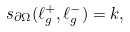Convert formula to latex. <formula><loc_0><loc_0><loc_500><loc_500>s _ { \partial \Omega } ( \ell ^ { + } _ { g } , \ell ^ { - } _ { g } ) = k ,</formula> 